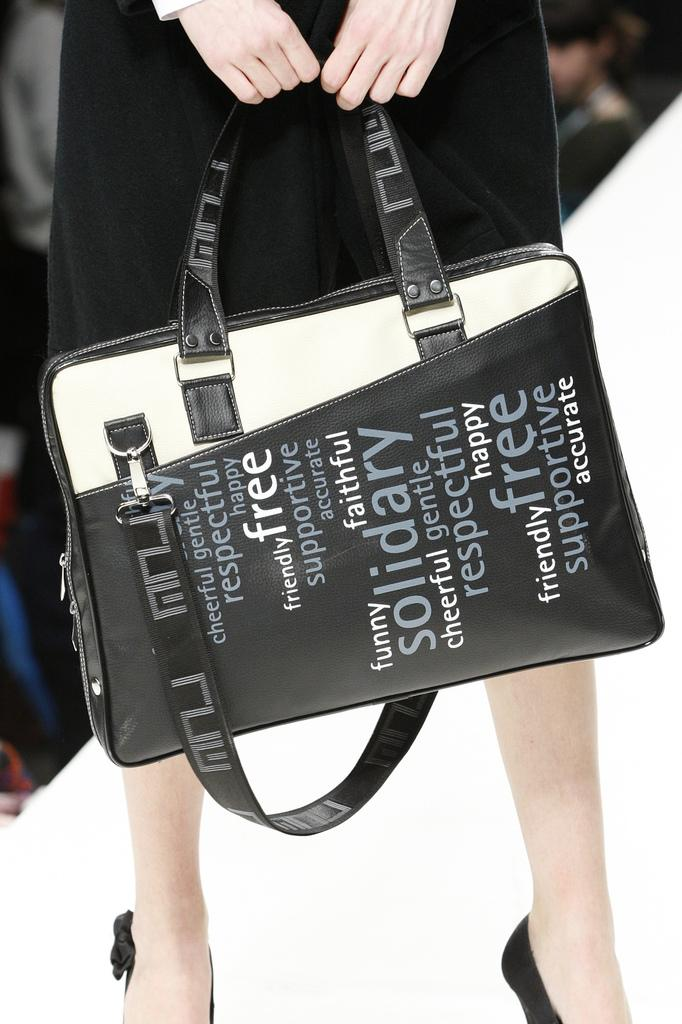Who is the main subject in the image? There is a woman in the middle of the image. What is the woman holding in the image? The woman is holding a handbag. Can you describe the handbag in more detail? Yes, there is text written on the handbag. What is the woman wearing in the image? The woman is wearing a black dress. What else can be seen in the image besides the woman? There are people in the background of the image. What type of crack can be seen on the woman's dress in the image? There is no crack visible on the woman's dress in the image. What cable is connected to the woman's handbag in the image? There is no cable connected to the woman's handbag in the image. 